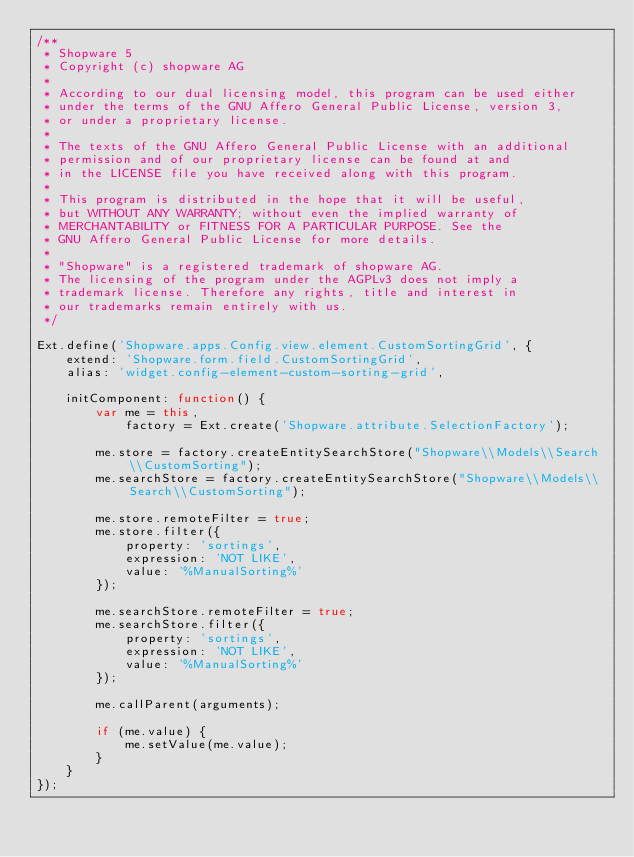<code> <loc_0><loc_0><loc_500><loc_500><_JavaScript_>/**
 * Shopware 5
 * Copyright (c) shopware AG
 *
 * According to our dual licensing model, this program can be used either
 * under the terms of the GNU Affero General Public License, version 3,
 * or under a proprietary license.
 *
 * The texts of the GNU Affero General Public License with an additional
 * permission and of our proprietary license can be found at and
 * in the LICENSE file you have received along with this program.
 *
 * This program is distributed in the hope that it will be useful,
 * but WITHOUT ANY WARRANTY; without even the implied warranty of
 * MERCHANTABILITY or FITNESS FOR A PARTICULAR PURPOSE. See the
 * GNU Affero General Public License for more details.
 *
 * "Shopware" is a registered trademark of shopware AG.
 * The licensing of the program under the AGPLv3 does not imply a
 * trademark license. Therefore any rights, title and interest in
 * our trademarks remain entirely with us.
 */

Ext.define('Shopware.apps.Config.view.element.CustomSortingGrid', {
    extend: 'Shopware.form.field.CustomSortingGrid',
    alias: 'widget.config-element-custom-sorting-grid',

    initComponent: function() {
        var me = this,
            factory = Ext.create('Shopware.attribute.SelectionFactory');

        me.store = factory.createEntitySearchStore("Shopware\\Models\\Search\\CustomSorting");
        me.searchStore = factory.createEntitySearchStore("Shopware\\Models\\Search\\CustomSorting");

        me.store.remoteFilter = true;
        me.store.filter({
            property: 'sortings',
            expression: 'NOT LIKE',
            value: '%ManualSorting%'
        });

        me.searchStore.remoteFilter = true;
        me.searchStore.filter({
            property: 'sortings',
            expression: 'NOT LIKE',
            value: '%ManualSorting%'
        });

        me.callParent(arguments);

        if (me.value) {
            me.setValue(me.value);
        }
    }
});
</code> 